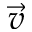<formula> <loc_0><loc_0><loc_500><loc_500>\vec { v }</formula> 